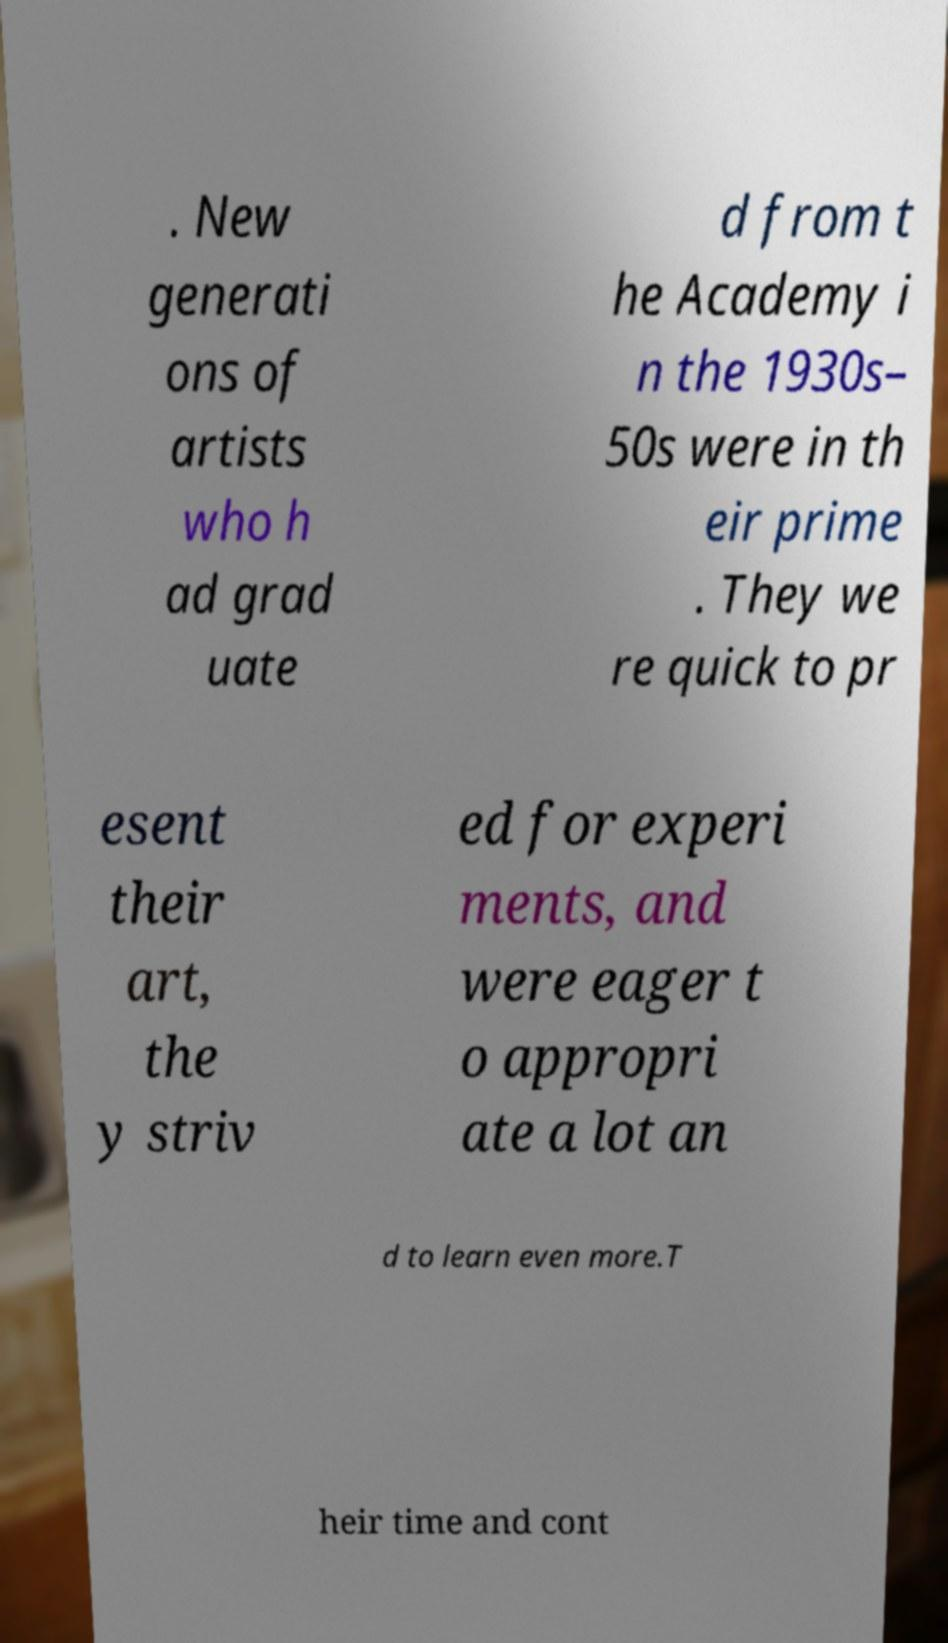I need the written content from this picture converted into text. Can you do that? . New generati ons of artists who h ad grad uate d from t he Academy i n the 1930s– 50s were in th eir prime . They we re quick to pr esent their art, the y striv ed for experi ments, and were eager t o appropri ate a lot an d to learn even more.T heir time and cont 